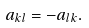<formula> <loc_0><loc_0><loc_500><loc_500>a _ { k l } = - a _ { l k } .</formula> 